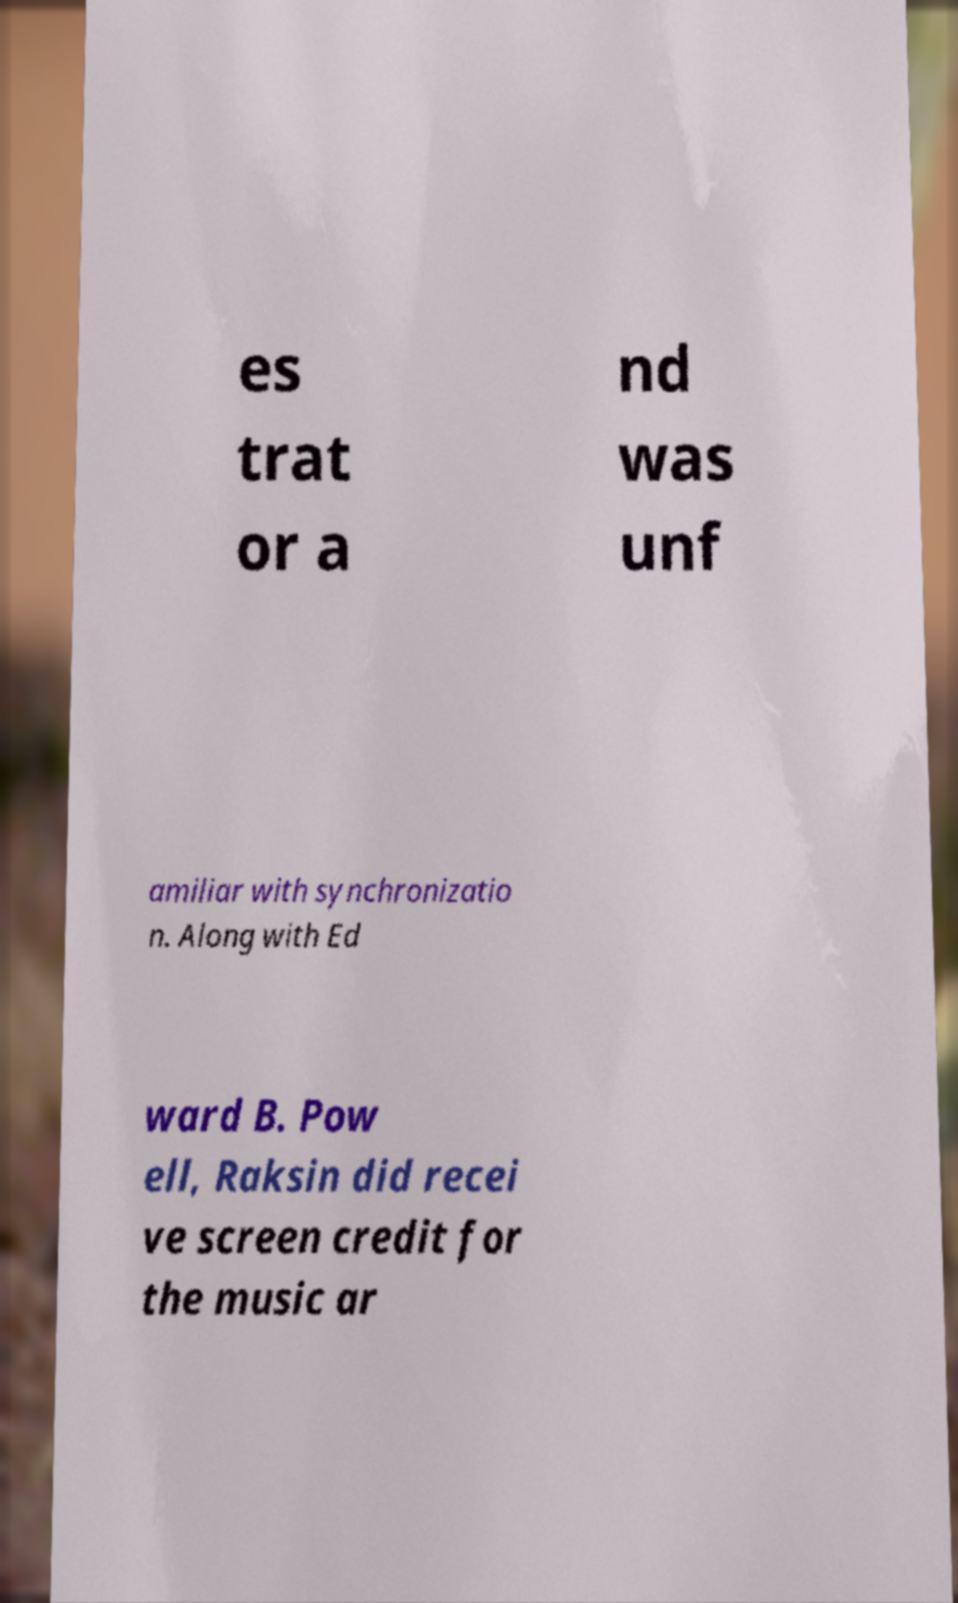There's text embedded in this image that I need extracted. Can you transcribe it verbatim? es trat or a nd was unf amiliar with synchronizatio n. Along with Ed ward B. Pow ell, Raksin did recei ve screen credit for the music ar 